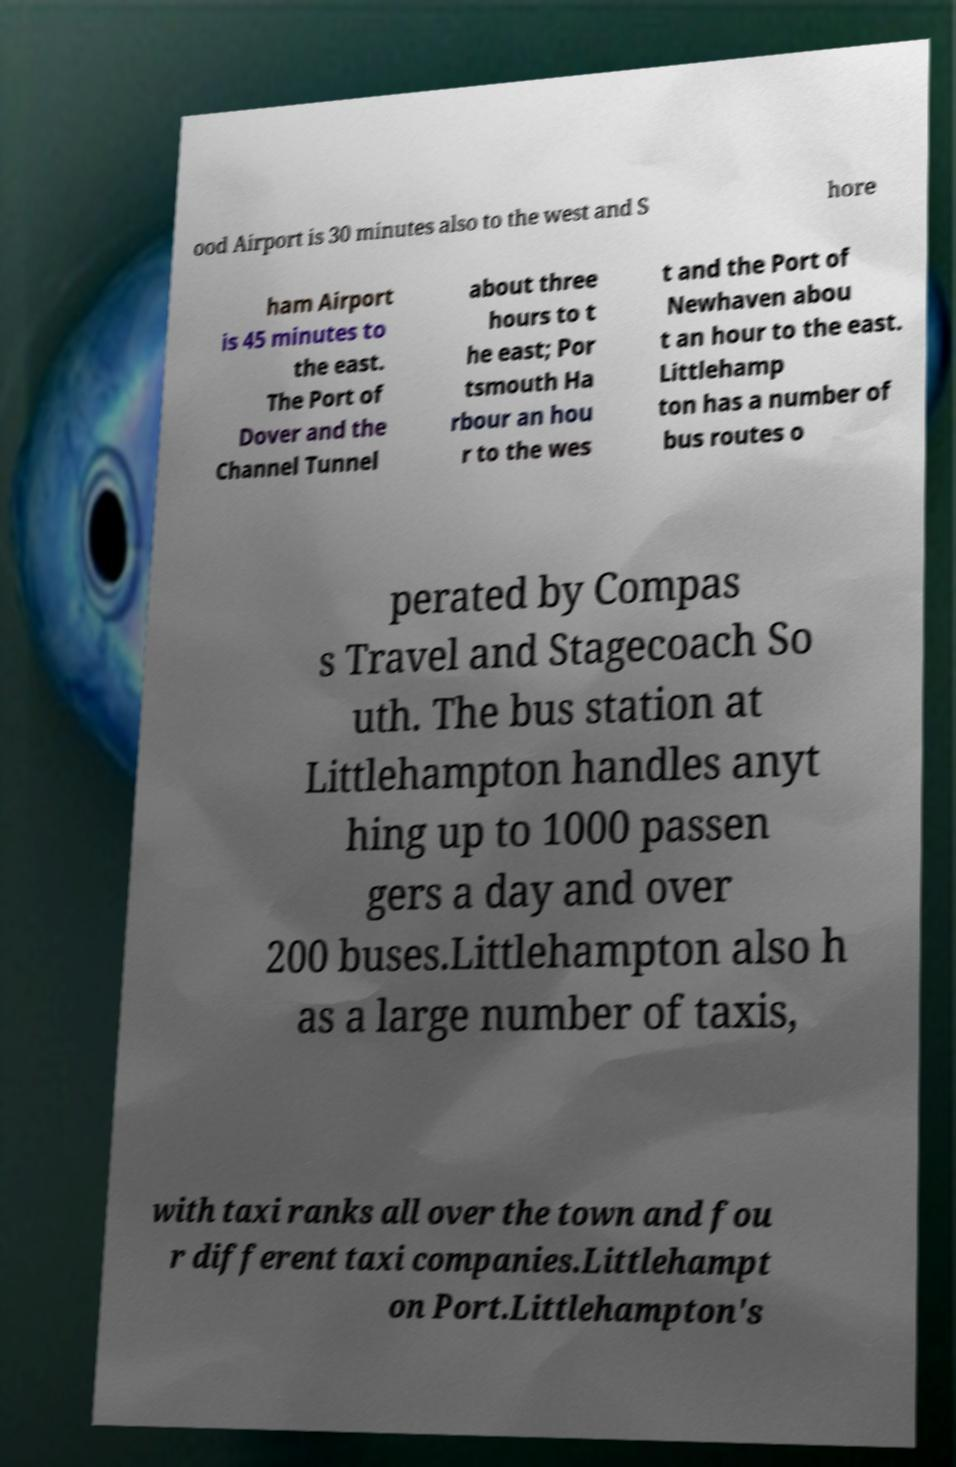There's text embedded in this image that I need extracted. Can you transcribe it verbatim? ood Airport is 30 minutes also to the west and S hore ham Airport is 45 minutes to the east. The Port of Dover and the Channel Tunnel about three hours to t he east; Por tsmouth Ha rbour an hou r to the wes t and the Port of Newhaven abou t an hour to the east. Littlehamp ton has a number of bus routes o perated by Compas s Travel and Stagecoach So uth. The bus station at Littlehampton handles anyt hing up to 1000 passen gers a day and over 200 buses.Littlehampton also h as a large number of taxis, with taxi ranks all over the town and fou r different taxi companies.Littlehampt on Port.Littlehampton's 